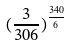<formula> <loc_0><loc_0><loc_500><loc_500>( \frac { 3 } { 3 0 6 } ) ^ { \frac { 3 4 0 } { 6 } }</formula> 